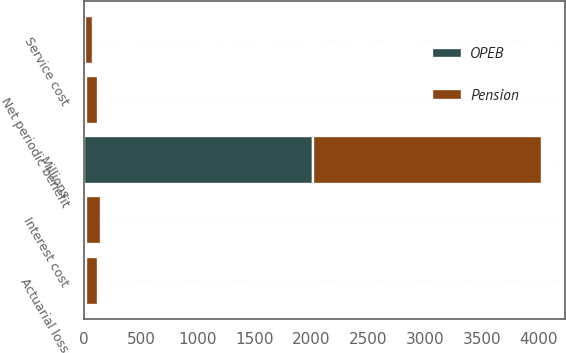<chart> <loc_0><loc_0><loc_500><loc_500><stacked_bar_chart><ecel><fcel>Millions<fcel>Service cost<fcel>Interest cost<fcel>Actuarial loss<fcel>Net periodic benefit<nl><fcel>Pension<fcel>2013<fcel>72<fcel>134<fcel>106<fcel>110<nl><fcel>OPEB<fcel>2013<fcel>3<fcel>12<fcel>15<fcel>14<nl></chart> 